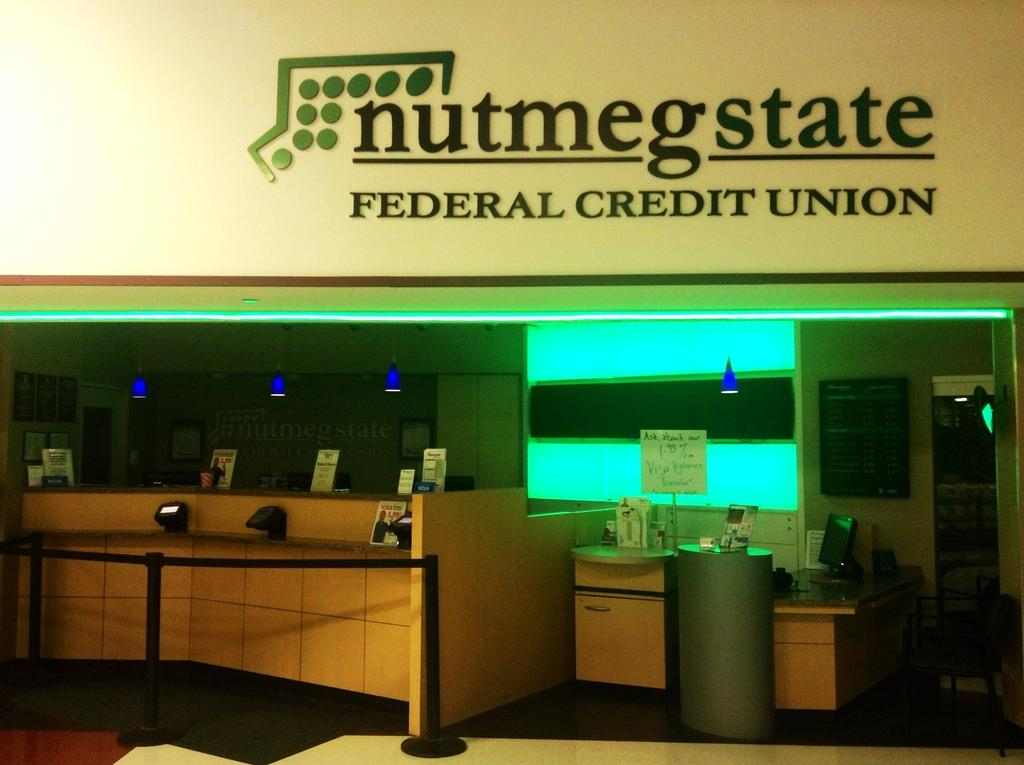<image>
Provide a brief description of the given image. A lobby and desk area of a credit union. 